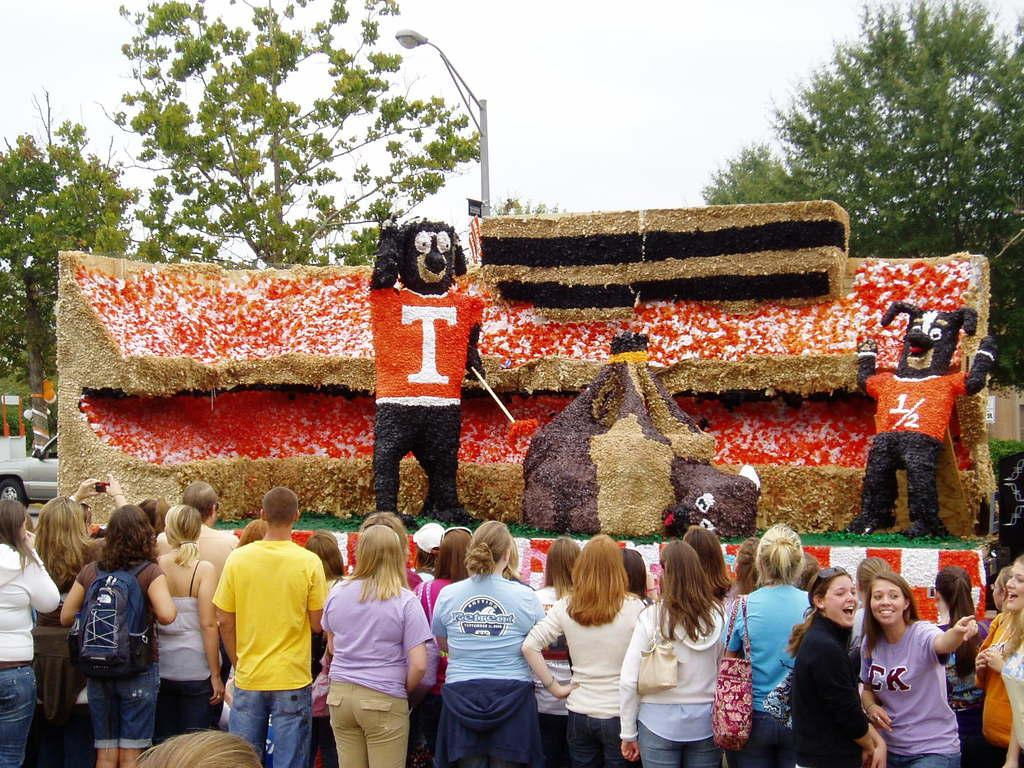How many people are in the image? There is a group of people in the image, but the exact number cannot be determined from the provided facts. What else can be seen in the image besides the people? There are toys in the image. What can be seen in the background of the image? There are trees, a pole, and the sky visible in the background of the image. Can you tell me how many giraffes are present in the image? There are no giraffes present in the image; it features a group of people and toys. What is the digestive system of the umbrella in the image? There is no umbrella present in the image, so it is not possible to discuss its digestive system. 